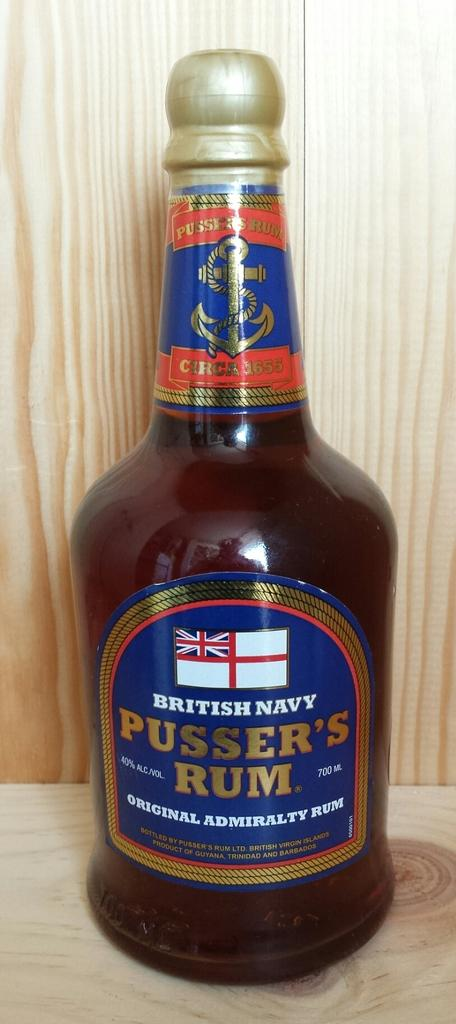<image>
Give a short and clear explanation of the subsequent image. A brown bottle of British Navy Pusser's Rum. 